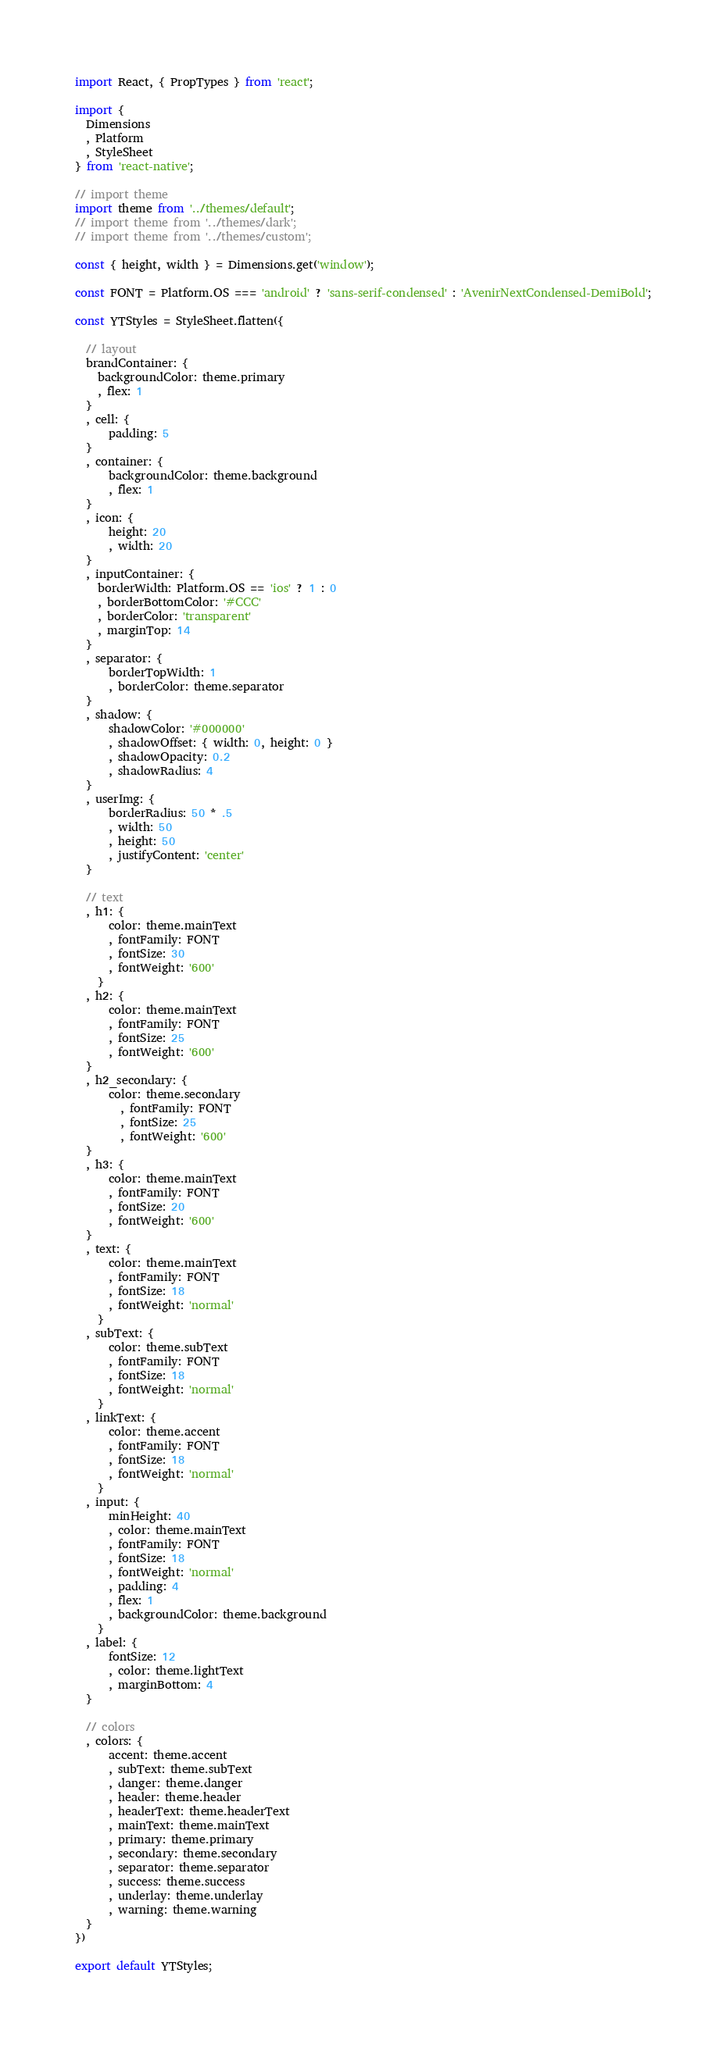Convert code to text. <code><loc_0><loc_0><loc_500><loc_500><_JavaScript_>import React, { PropTypes } from 'react';

import {
  Dimensions
  , Platform
  , StyleSheet
} from 'react-native'; 

// import theme
import theme from '../themes/default'; 
// import theme from '../themes/dark';
// import theme from '../themes/custom'; 

const { height, width } = Dimensions.get('window');

const FONT = Platform.OS === 'android' ? 'sans-serif-condensed' : 'AvenirNextCondensed-DemiBold';

const YTStyles = StyleSheet.flatten({

  // layout
  brandContainer: {
    backgroundColor: theme.primary
    , flex: 1
  }
  , cell: {
      padding: 5
  }
  , container: {
      backgroundColor: theme.background
      , flex: 1
  }
  , icon: {
      height: 20
      , width: 20
  }
  , inputContainer: {
    borderWidth: Platform.OS == 'ios' ? 1 : 0
    , borderBottomColor: '#CCC'
    , borderColor: 'transparent'
    , marginTop: 14
  }
  , separator: {
      borderTopWidth: 1
      , borderColor: theme.separator
  }
  , shadow: {
      shadowColor: '#000000'
      , shadowOffset: { width: 0, height: 0 }
      , shadowOpacity: 0.2
      , shadowRadius: 4
  }
  , userImg: {
      borderRadius: 50 * .5
      , width: 50
      , height: 50
      , justifyContent: 'center'
  }

  // text
  , h1: {
      color: theme.mainText
      , fontFamily: FONT
      , fontSize: 30
      , fontWeight: '600'
    }
  , h2: {
      color: theme.mainText
      , fontFamily: FONT
      , fontSize: 25
      , fontWeight: '600'
  }
  , h2_secondary: {
      color: theme.secondary
        , fontFamily: FONT
        , fontSize: 25
        , fontWeight: '600'
  }
  , h3: {
      color: theme.mainText
      , fontFamily: FONT
      , fontSize: 20
      , fontWeight: '600'
  }
  , text: {
      color: theme.mainText
      , fontFamily: FONT
      , fontSize: 18
      , fontWeight: 'normal'
    }
  , subText: {
      color: theme.subText
      , fontFamily: FONT
      , fontSize: 18
      , fontWeight: 'normal'
    }
  , linkText: {
      color: theme.accent
      , fontFamily: FONT
      , fontSize: 18
      , fontWeight: 'normal'
    }
  , input: {
      minHeight: 40
      , color: theme.mainText
      , fontFamily: FONT
      , fontSize: 18
      , fontWeight: 'normal'
      , padding: 4
      , flex: 1
      , backgroundColor: theme.background
    }
  , label: {
      fontSize: 12
      , color: theme.lightText
      , marginBottom: 4
  }

  // colors
  , colors: {
      accent: theme.accent
      , subText: theme.subText
      , danger: theme.danger
      , header: theme.header
      , headerText: theme.headerText
      , mainText: theme.mainText
      , primary: theme.primary
      , secondary: theme.secondary
      , separator: theme.separator
      , success: theme.success
      , underlay: theme.underlay
      , warning: theme.warning
  }
})

export default YTStyles; </code> 